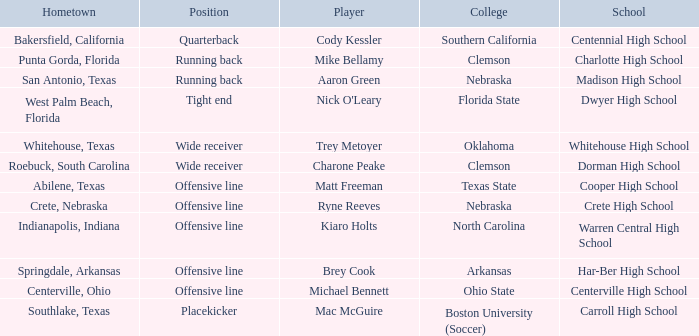What college did Matt Freeman go to? Texas State. 